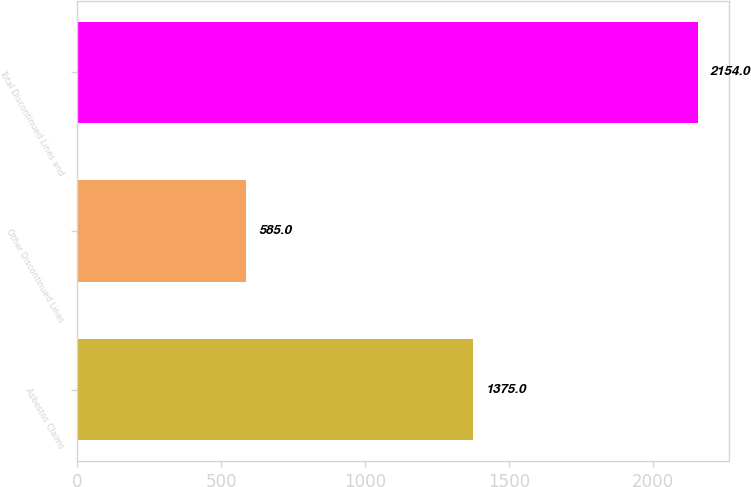Convert chart to OTSL. <chart><loc_0><loc_0><loc_500><loc_500><bar_chart><fcel>Asbestos Claims<fcel>Other Discontinued Lines<fcel>Total Discontinued Lines and<nl><fcel>1375<fcel>585<fcel>2154<nl></chart> 